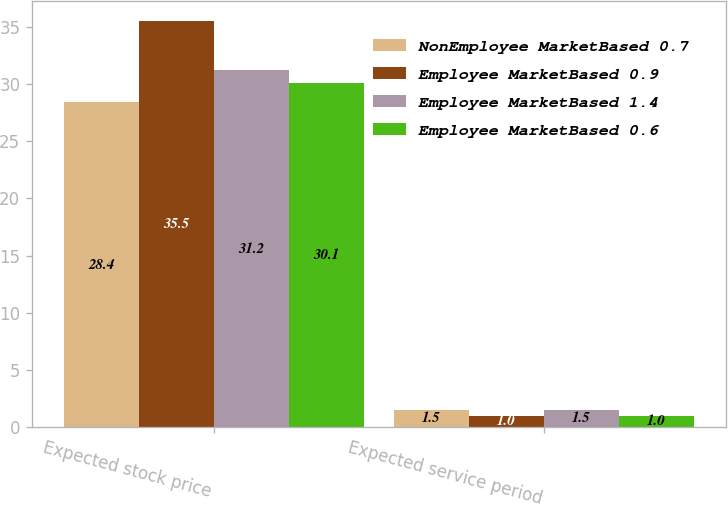Convert chart. <chart><loc_0><loc_0><loc_500><loc_500><stacked_bar_chart><ecel><fcel>Expected stock price<fcel>Expected service period<nl><fcel>NonEmployee MarketBased 0.7<fcel>28.4<fcel>1.5<nl><fcel>Employee MarketBased 0.9<fcel>35.5<fcel>1<nl><fcel>Employee MarketBased 1.4<fcel>31.2<fcel>1.5<nl><fcel>Employee MarketBased 0.6<fcel>30.1<fcel>1<nl></chart> 